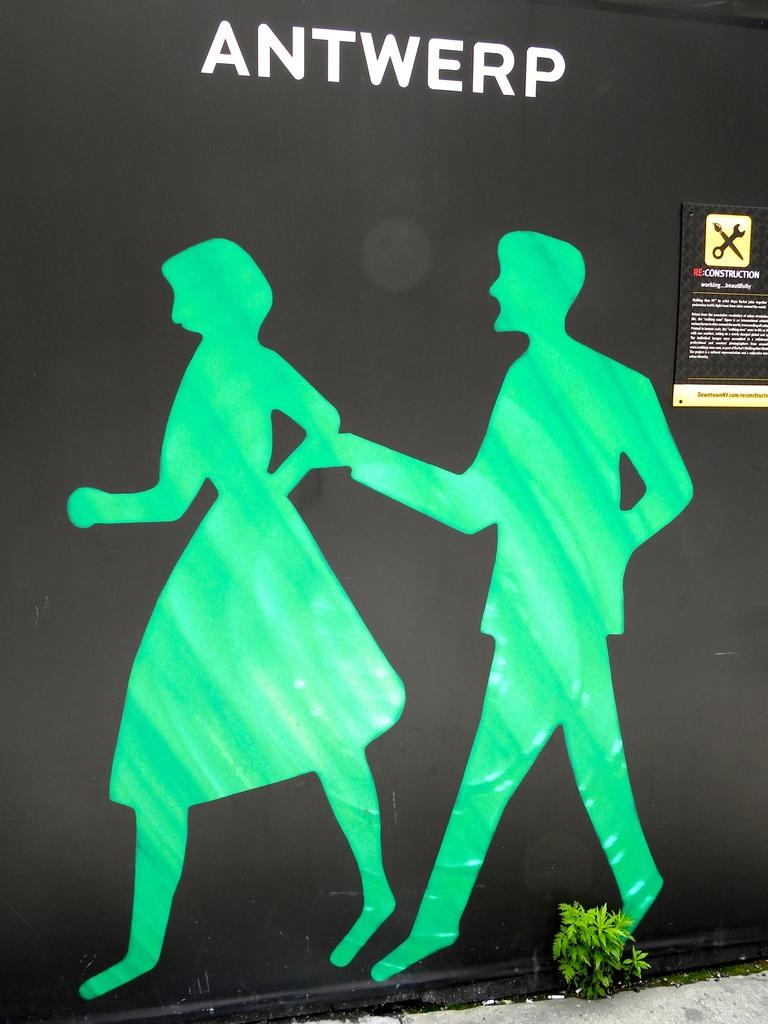<image>
Provide a brief description of the given image. Black cover with a silhouette of a man and woman as well as the word "ANTWERP". 